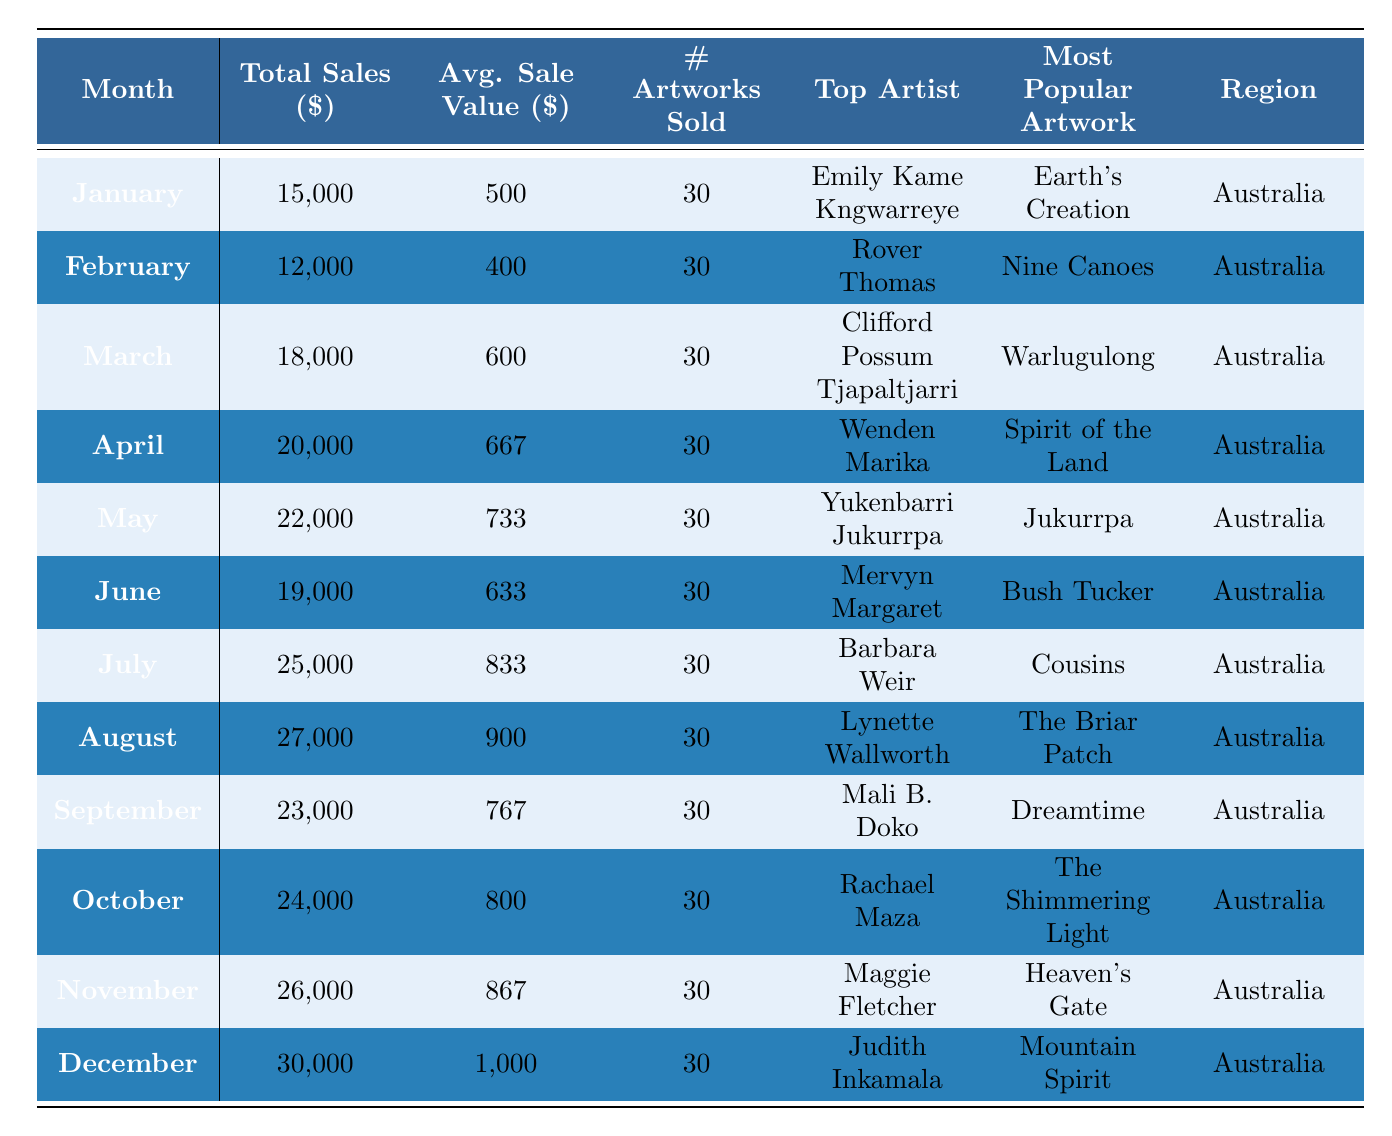What was the total sales in December? The table shows that the total sales for December is listed as 30,000.
Answer: 30,000 Who was the top artist in July? According to the table, the top artist in July is Barbara Weir.
Answer: Barbara Weir What was the average sale value in November? The average sale value for November is shown as 867.
Answer: 867 How many artworks were sold in March? The table indicates that in March, 30 artworks were sold.
Answer: 30 What is the highest total sales month? By comparing all the total sales values, December has the highest total sales at 30,000.
Answer: December What was the average sales value from January to June? The average can be calculated by summing the average sales values from January to June (500 + 400 + 600 + 667 + 733 + 633) = 3500 and dividing it by 6, which gives an average of approximately 583.33.
Answer: 583.33 Was the most popular artwork in August "The Briar Patch"? Yes, the table confirms that the most popular artwork in August is indeed "The Briar Patch."
Answer: Yes What is the total sales from July to September? Adding the total sales for July (25,000), August (27,000), and September (23,000) gives us 25,000 + 27,000 + 23,000 = 75,000.
Answer: 75,000 Which artist had the highest average sale value, and what was it? Upon reviewing the average sale values, December, with Judith Inkamala, has the highest average sale value of 1,000.
Answer: Judith Inkamala, 1,000 What was the improvement in total sales from January to December? Total sales in January were 15,000, and in December, it was 30,000. The improvement is calculated as 30,000 - 15,000 = 15,000.
Answer: 15,000 Which month had the lowest average sale value? February is the month with the lowest average sale value of 400 according to the table data.
Answer: February, 400 